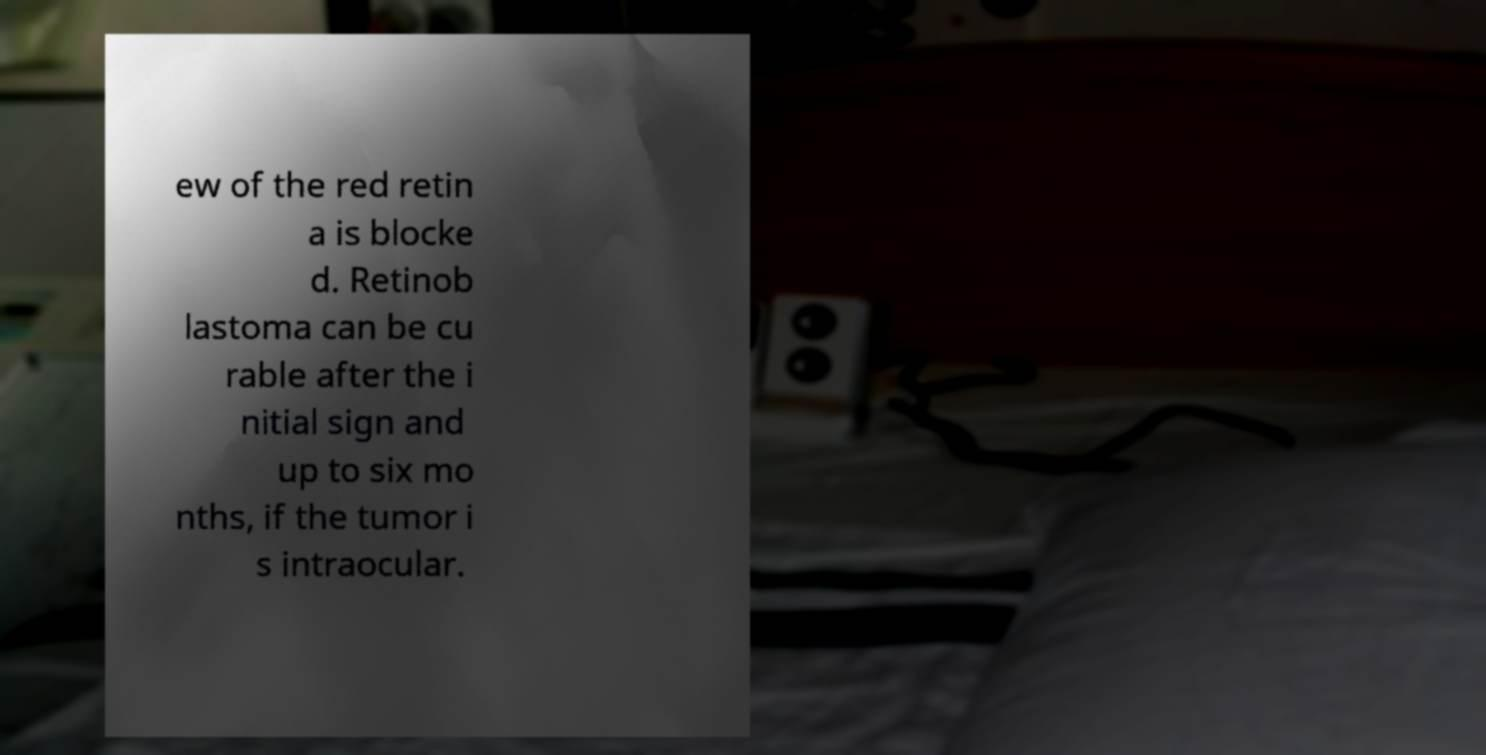Please identify and transcribe the text found in this image. ew of the red retin a is blocke d. Retinob lastoma can be cu rable after the i nitial sign and up to six mo nths, if the tumor i s intraocular. 